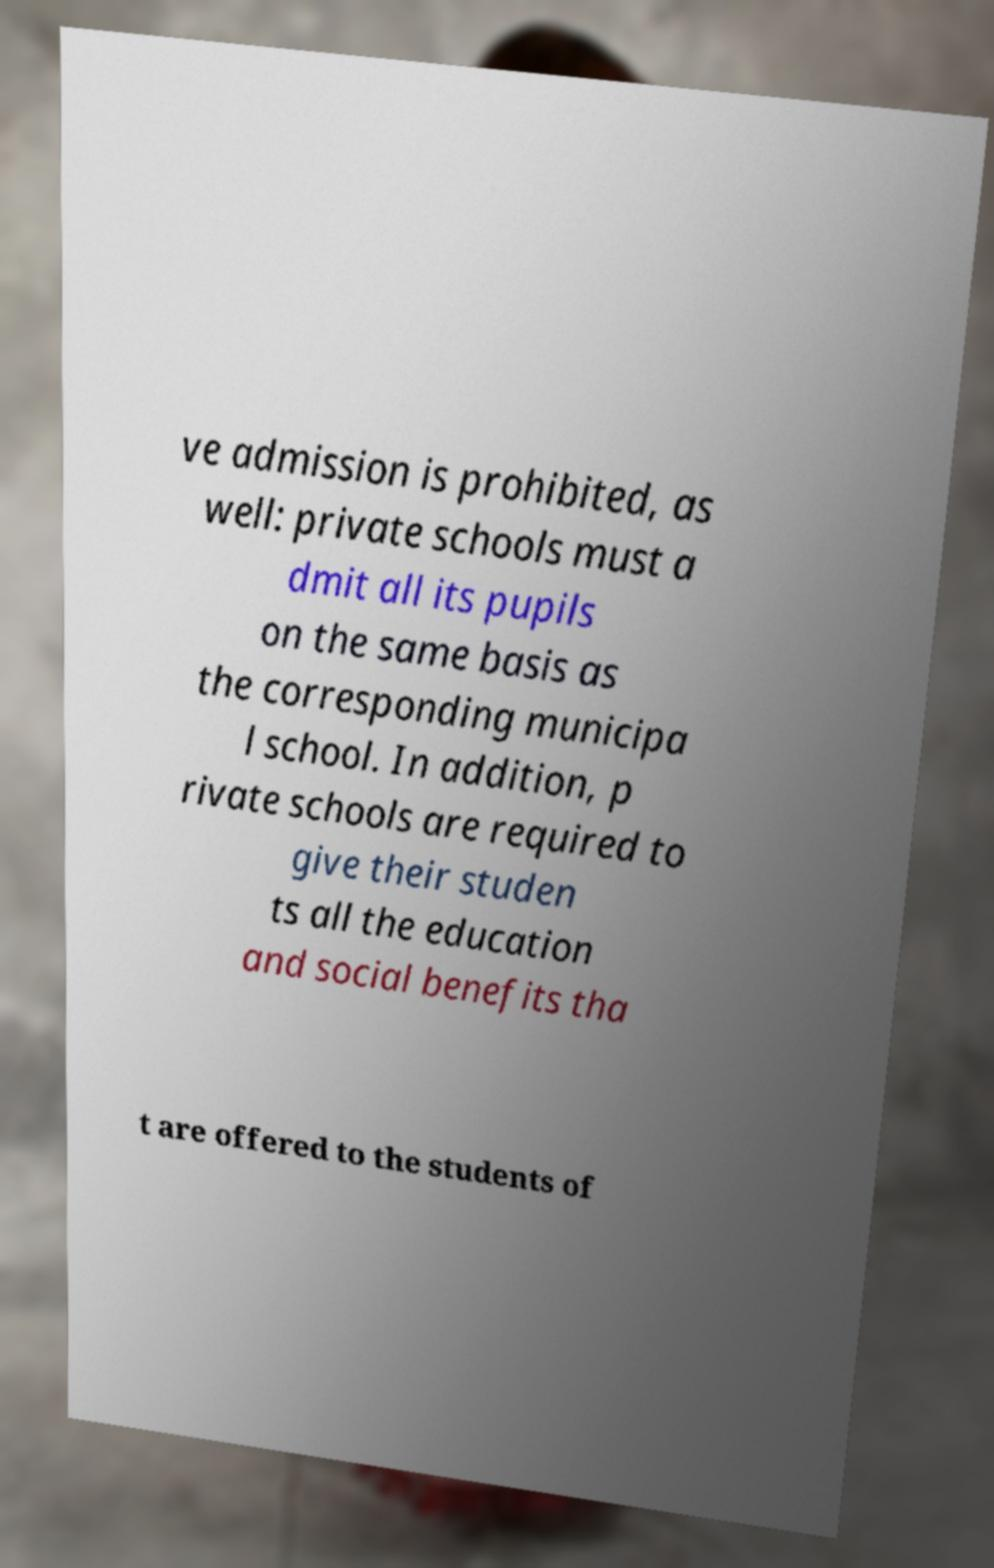Please read and relay the text visible in this image. What does it say? ve admission is prohibited, as well: private schools must a dmit all its pupils on the same basis as the corresponding municipa l school. In addition, p rivate schools are required to give their studen ts all the education and social benefits tha t are offered to the students of 